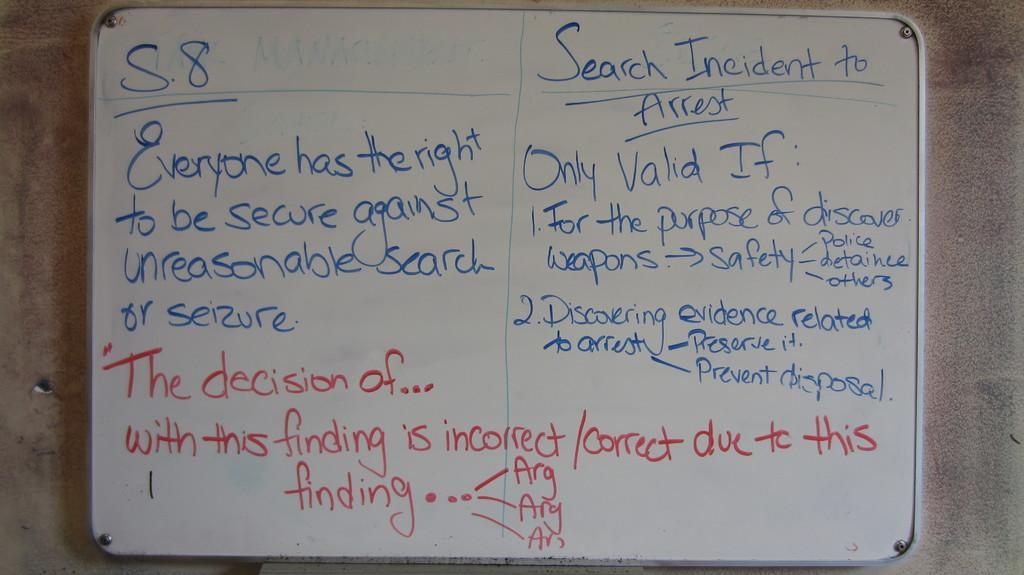Provide a one-sentence caption for the provided image. A Board showing everyone's rights against search and seizure and when it is valid. 